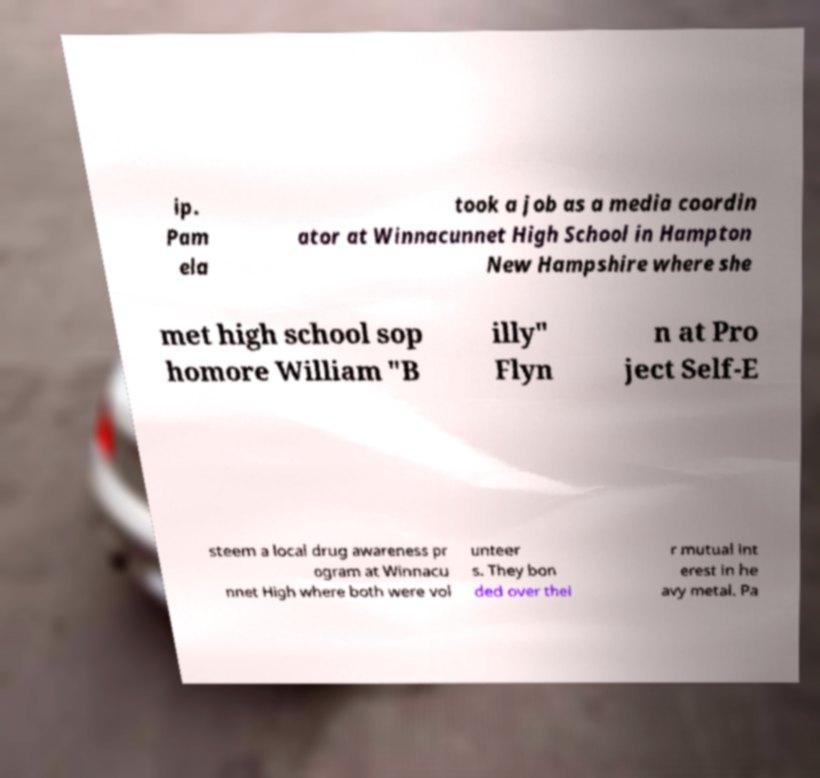Could you extract and type out the text from this image? ip. Pam ela took a job as a media coordin ator at Winnacunnet High School in Hampton New Hampshire where she met high school sop homore William "B illy" Flyn n at Pro ject Self-E steem a local drug awareness pr ogram at Winnacu nnet High where both were vol unteer s. They bon ded over thei r mutual int erest in he avy metal. Pa 